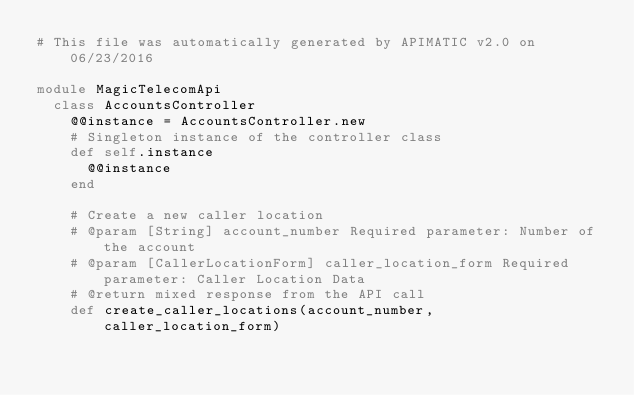<code> <loc_0><loc_0><loc_500><loc_500><_Ruby_># This file was automatically generated by APIMATIC v2.0 on 06/23/2016

module MagicTelecomApi
  class AccountsController
    @@instance = AccountsController.new
    # Singleton instance of the controller class
    def self.instance
      @@instance
    end

    # Create a new caller location
    # @param [String] account_number Required parameter: Number of the account
    # @param [CallerLocationForm] caller_location_form Required parameter: Caller Location Data
    # @return mixed response from the API call
    def create_caller_locations(account_number, caller_location_form)</code> 